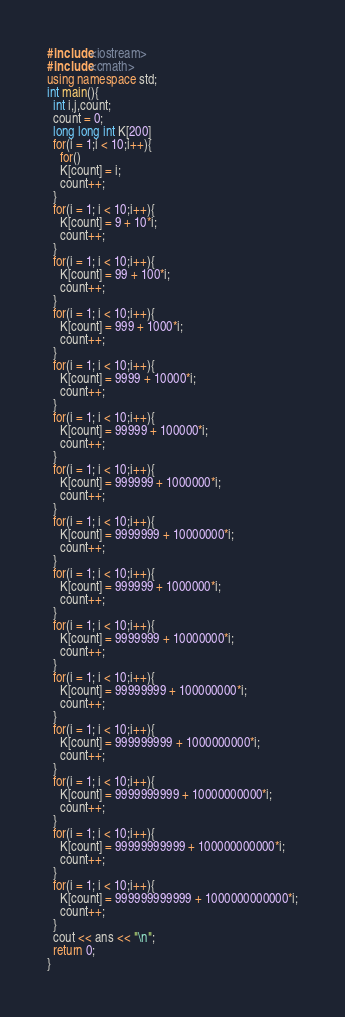<code> <loc_0><loc_0><loc_500><loc_500><_C++_>#include<iostream>
#include<cmath>
using namespace std;
int main(){
  int i,j,count;
  count = 0;
  long long int K[200]
  for(i = 1;i < 10;i++){
    for()
    K[count] = i;
    count++;
  }
  for(i = 1; i < 10;i++){
    K[count] = 9 + 10*i;
    count++;
  }
  for(i = 1; i < 10;i++){
    K[count] = 99 + 100*i;
    count++;
  }
  for(i = 1; i < 10;i++){
    K[count] = 999 + 1000*i;
    count++;
  }
  for(i = 1; i < 10;i++){
    K[count] = 9999 + 10000*i;
    count++;
  }
  for(i = 1; i < 10;i++){
    K[count] = 99999 + 100000*i;
    count++;
  }
  for(i = 1; i < 10;i++){
    K[count] = 999999 + 1000000*i;
    count++;
  }
  for(i = 1; i < 10;i++){
    K[count] = 9999999 + 10000000*i;
    count++;
  }
  for(i = 1; i < 10;i++){
    K[count] = 999999 + 1000000*i;
    count++;
  }
  for(i = 1; i < 10;i++){
    K[count] = 9999999 + 10000000*i;
    count++;
  }
  for(i = 1; i < 10;i++){
    K[count] = 99999999 + 100000000*i;
    count++;
  }
  for(i = 1; i < 10;i++){
    K[count] = 999999999 + 1000000000*i;
    count++;
  }
  for(i = 1; i < 10;i++){
    K[count] = 9999999999 + 10000000000*i;
    count++;
  }
  for(i = 1; i < 10;i++){
    K[count] = 99999999999 + 100000000000*i;
    count++;
  }
  for(i = 1; i < 10;i++){
    K[count] = 999999999999 + 1000000000000*i;
    count++;
  }
  cout << ans << "\n";
  return 0;
}</code> 